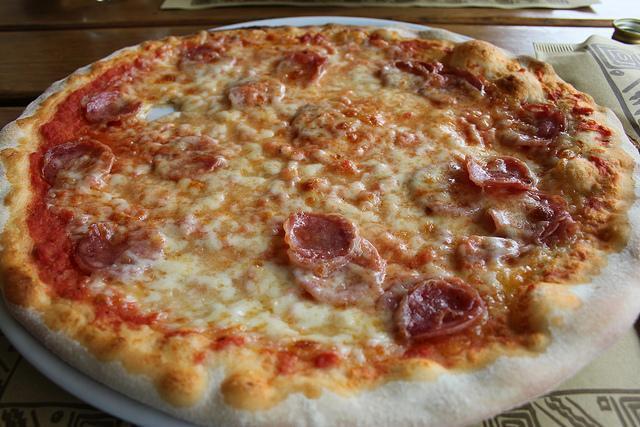How many buses are there?
Give a very brief answer. 0. 